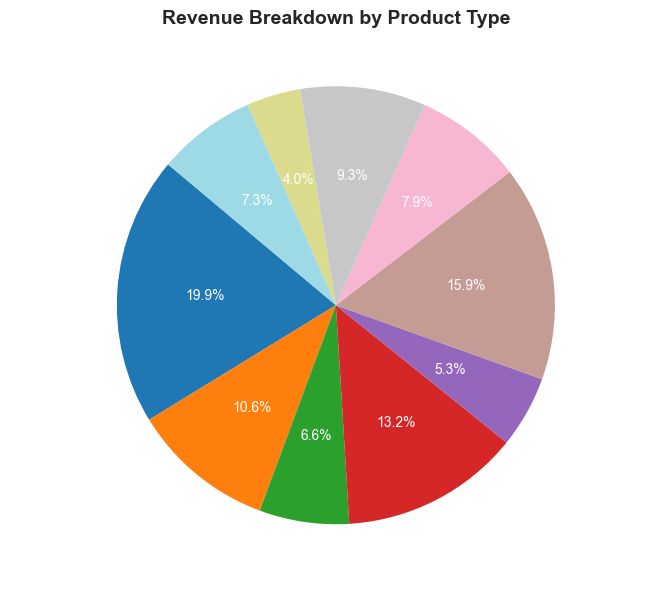What percentage of total revenue comes from Board Games and RPG Books combined? Add the percentages of revenue from Board Games (25.0%) and RPG Books (16.7%) from the pie chart.
Answer: 41.7% Which product type has the smallest revenue share? Identify the segment in the pie chart with the smallest percentage. Merchandise accounts for only 5.0% of the total revenue.
Answer: Merchandise How does the revenue from Card Games compare to that from Comics? Refer to the percentages: Card Games are 8.3% while Comics are 10.0%, so Comics contribute a higher percentage of revenue than Card Games.
Answer: Comics Is the revenue from Video Games greater than the combined revenue of Accessories and Collectibles? Compare Video Games' share (20.0%) to the combined percentage of Accessories (6.7%) and Collectibles (11.7%), total being 18.4%. Video Games' share is larger.
Answer: Yes Which product types together make up more than half of the total revenue? Examine the chart to identify the segments that add up to more than 50%. Board Games (25.0%) and Video Games (20.0%) combined already make 45.0%. Including RPG Books (16.7%) makes a cumulative total of 61.7%.
Answer: Board Games, Video Games, and RPG Books How much more revenue percentage do Board Games generate compared to Miniatures? Find the gap between Board Games (25.0%) and Miniatures (13.3%) by subtracting the smaller percentage from the larger one: 25.0% - 13.3% = 11.7%.
Answer: 11.7% Which visual attributes on the pie chart help identify the revenue distribution across different product types? The segments’ size and color aid in recognizing the revenue portions, with the labels providing percentages and names of the product types. Larger and more distinct segments indicate higher revenue shares.
Answer: Size and color of segments What is the combined revenue percentage of the least contributing four product types? Identify and sum the percentages of the four smallest segments: Merchandise (5.0%), Accessories (6.7%), Card Games (8.3%), and Expansion Packs (9.2%). Total: 5.0% + 6.7% + 8.3% + 9.2% = 29.2%.
Answer: 29.2% Is the revenue from Comics and Collectibles together greater than that from RPG Books? Add the revenues of Comics (10.0%) and Collectibles (11.7%) and compare to RPG Books (16.7%). The sum (21.7%) of Comics and Collectibles is greater than 16.7%.
Answer: Yes 